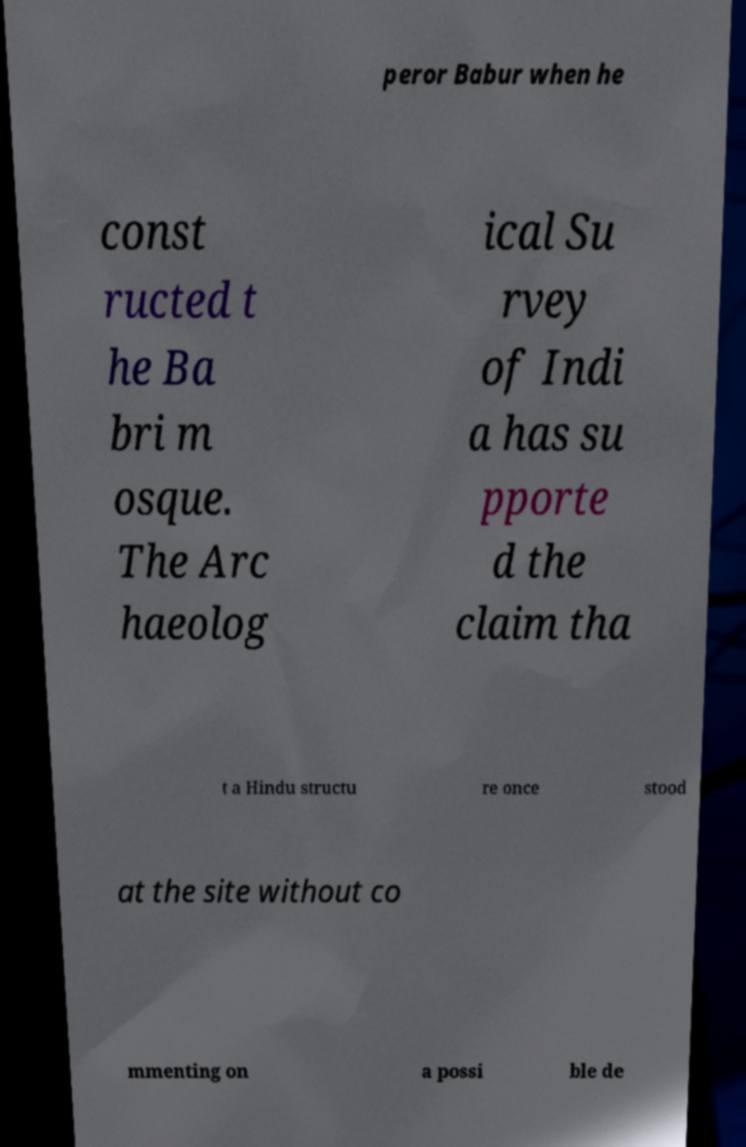Please read and relay the text visible in this image. What does it say? peror Babur when he const ructed t he Ba bri m osque. The Arc haeolog ical Su rvey of Indi a has su pporte d the claim tha t a Hindu structu re once stood at the site without co mmenting on a possi ble de 